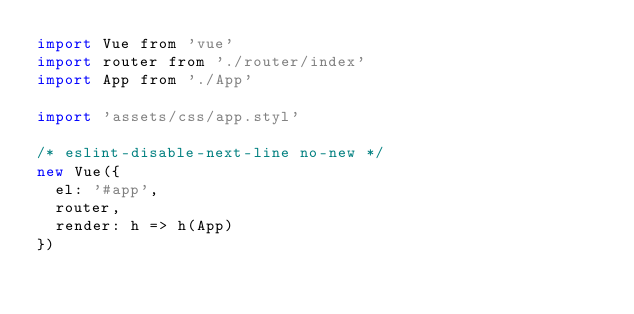Convert code to text. <code><loc_0><loc_0><loc_500><loc_500><_JavaScript_>import Vue from 'vue'
import router from './router/index'
import App from './App'

import 'assets/css/app.styl'

/* eslint-disable-next-line no-new */
new Vue({
  el: '#app',
  router,
  render: h => h(App)
})
</code> 